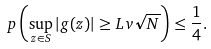Convert formula to latex. <formula><loc_0><loc_0><loc_500><loc_500>\ p \left ( \sup _ { z \in S } | g ( z ) | \geq L v \sqrt { N } \right ) \leq \frac { 1 } { 4 } .</formula> 